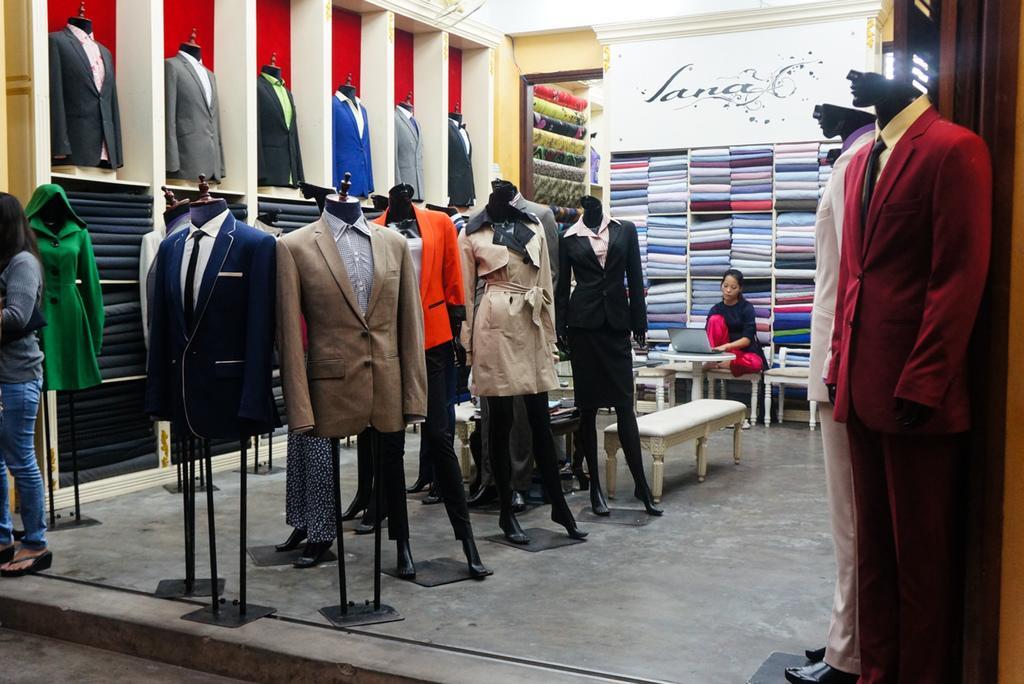In one or two sentences, can you explain what this image depicts? In this image there are suites, benches and chairs. At the center of the image there is a person sitting on the chair and in front of her there is a table and on top of the table there is a laptop. On the right side of the image there is a light. At the bottom of the image there is a floor and we can see a person on the left side of the image. 